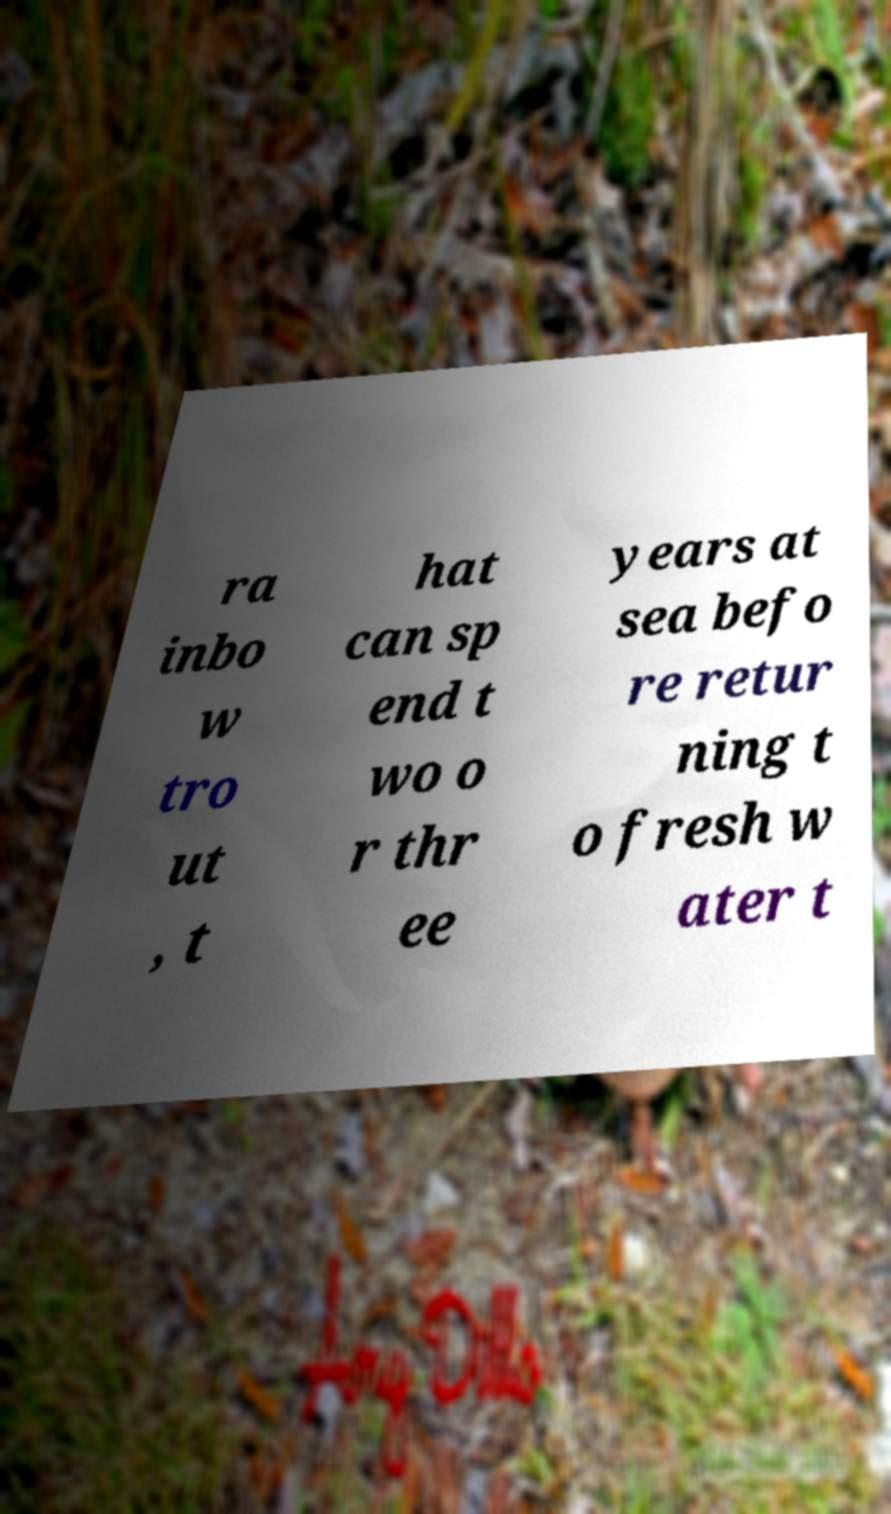Can you read and provide the text displayed in the image?This photo seems to have some interesting text. Can you extract and type it out for me? ra inbo w tro ut , t hat can sp end t wo o r thr ee years at sea befo re retur ning t o fresh w ater t 